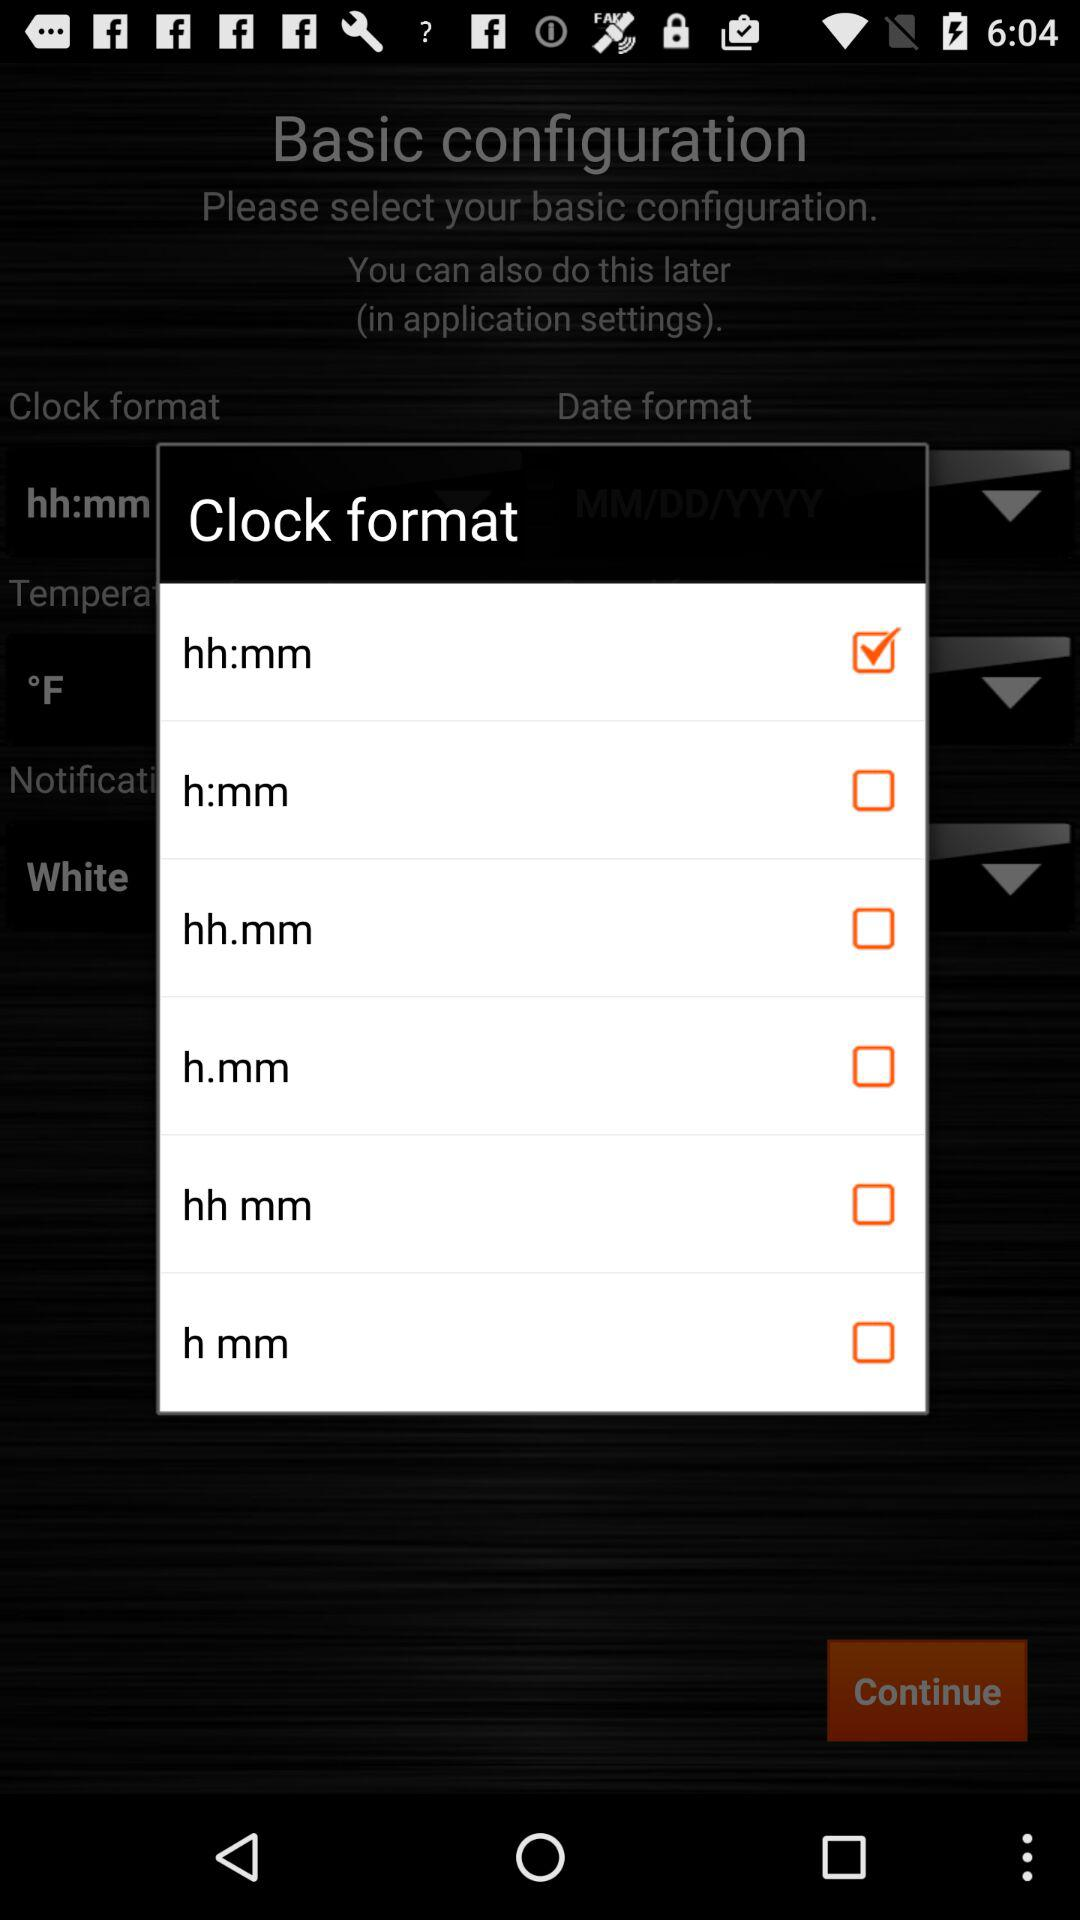How do we continue?
When the provided information is insufficient, respond with <no answer>. <no answer> 